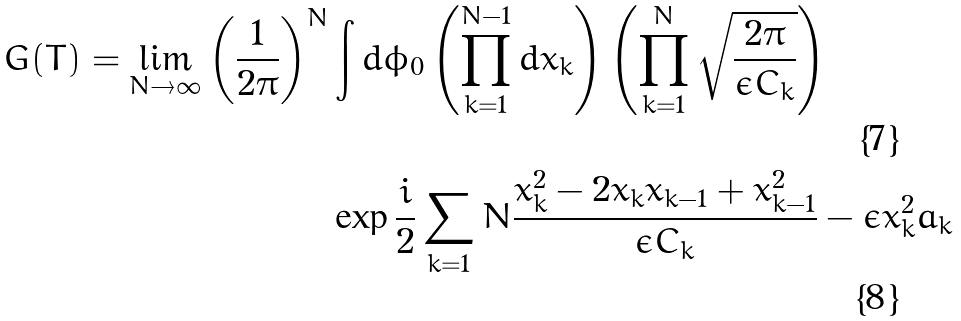<formula> <loc_0><loc_0><loc_500><loc_500>G ( T ) = \lim _ { N \to \infty } \left ( \frac { 1 } { 2 \pi } \right ) ^ { N } & \int d \phi _ { 0 } \left ( \prod _ { k = 1 } ^ { N - 1 } d x _ { k } \right ) \left ( \prod _ { k = 1 } ^ { N } \sqrt { \frac { 2 \pi } { \epsilon C _ { k } } } \right ) \\ & \exp { \frac { i } { 2 } \sum _ { k = 1 } { N } \frac { x _ { k } ^ { 2 } - 2 x _ { k } x _ { k - 1 } + x _ { k - 1 } ^ { 2 } } { \epsilon C _ { k } } - \epsilon x _ { k } ^ { 2 } a _ { k } }</formula> 